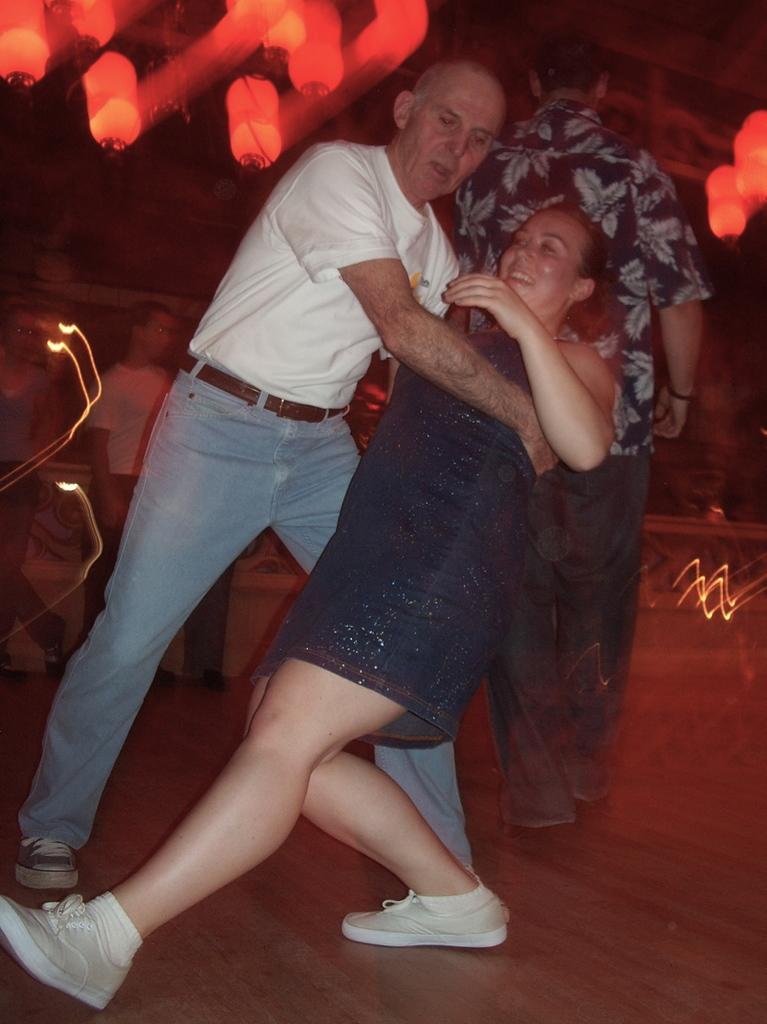Could you give a brief overview of what you see in this image? In this image there is a man and a woman in the dancing pose on the floor. Behind these persons there are persons standing. Lights are visible in this image. 